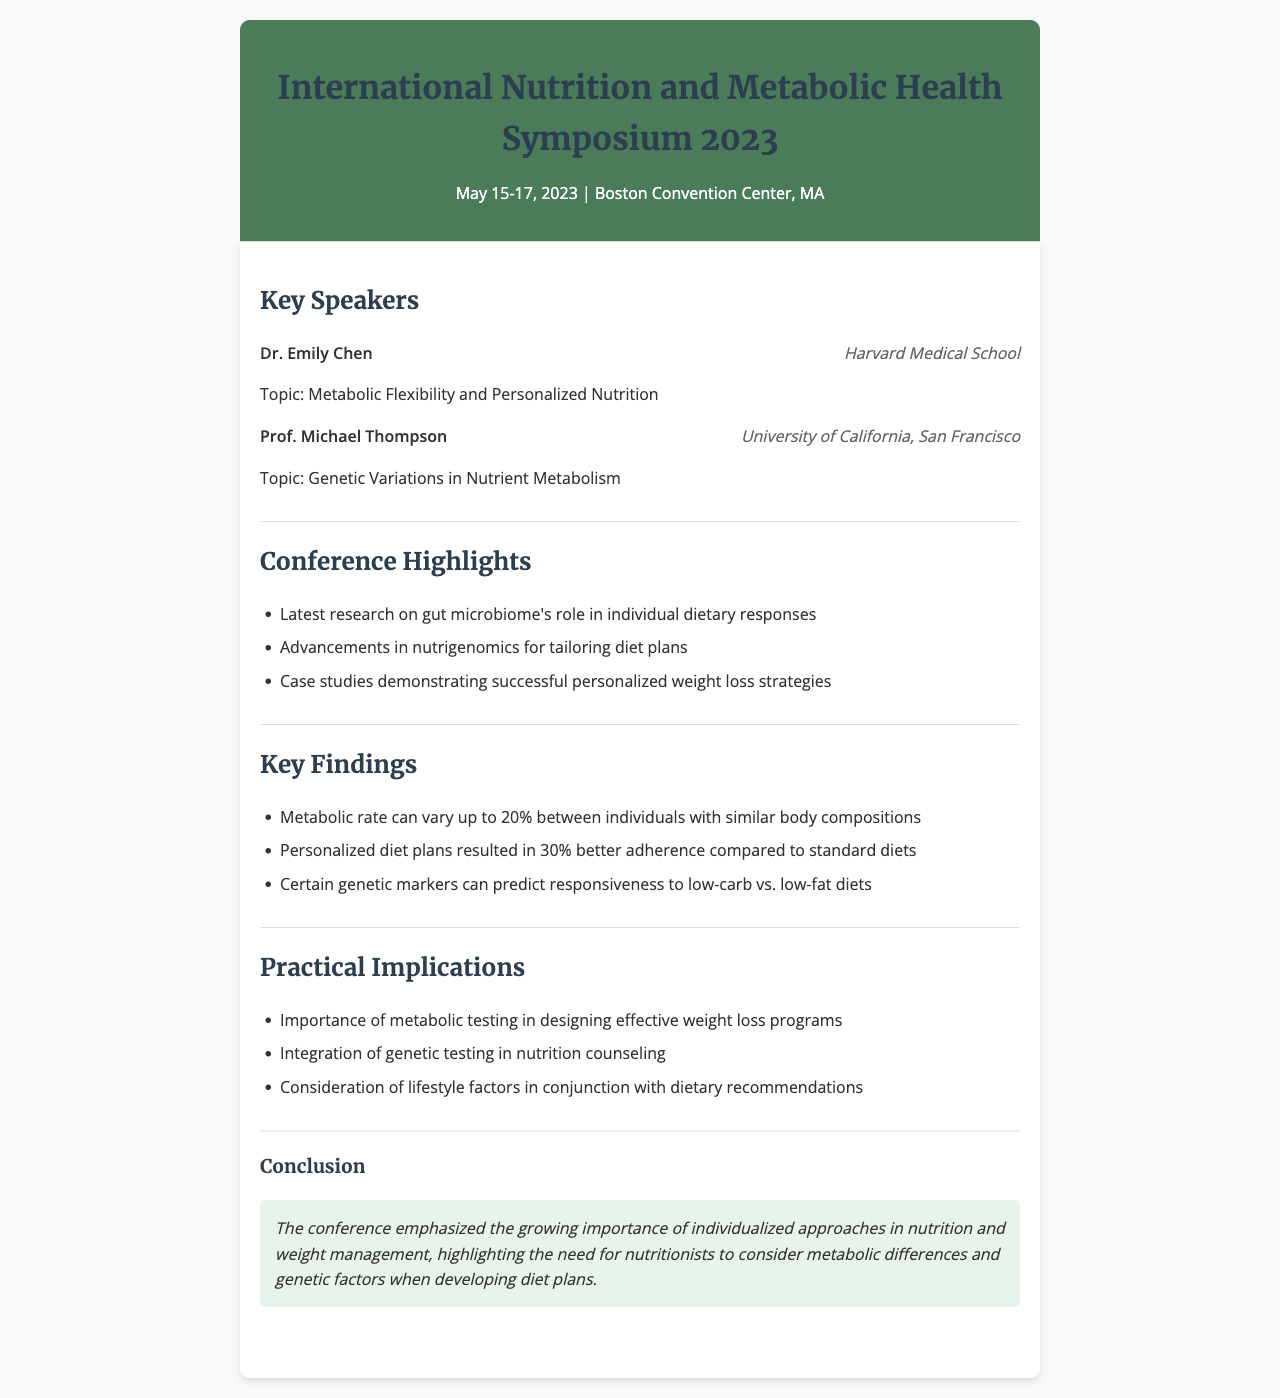What are the dates of the conference? The conference took place from May 15 to May 17, 2023.
Answer: May 15-17, 2023 Who is the speaker from Harvard Medical School? Dr. Emily Chen is the speaker representing Harvard Medical School.
Answer: Dr. Emily Chen What topic did Prof. Michael Thompson discuss? Prof. Michael Thompson spoke about Genetic Variations in Nutrient Metabolism.
Answer: Genetic Variations in Nutrient Metabolism What percentage better adherence did personalized diet plans achieve? Personalized diet plans resulted in 30% better adherence compared to standard diets.
Answer: 30% What is one practical implication of the conference findings? Importance of metabolic testing in designing effective weight loss programs is one implication mentioned.
Answer: Importance of metabolic testing How much can metabolic rates vary between individuals? The document states that metabolic rates can vary up to 20% between individuals.
Answer: 20% What is emphasized as important for nutritionists? The conclusion emphasizes the growing importance of individualized approaches in nutrition and weight management.
Answer: Individualized approaches What institution is Prof. Michael Thompson affiliated with? Prof. Michael Thompson is affiliated with the University of California, San Francisco.
Answer: University of California, San Francisco 